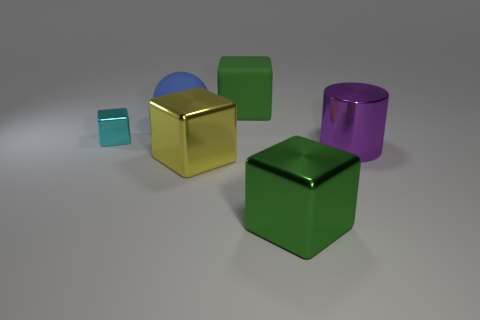Add 4 tiny green shiny cubes. How many objects exist? 10 Subtract all blocks. How many objects are left? 2 Subtract 0 gray spheres. How many objects are left? 6 Subtract all small blue cylinders. Subtract all tiny cyan metal things. How many objects are left? 5 Add 3 large metallic objects. How many large metallic objects are left? 6 Add 4 small cyan metallic balls. How many small cyan metallic balls exist? 4 